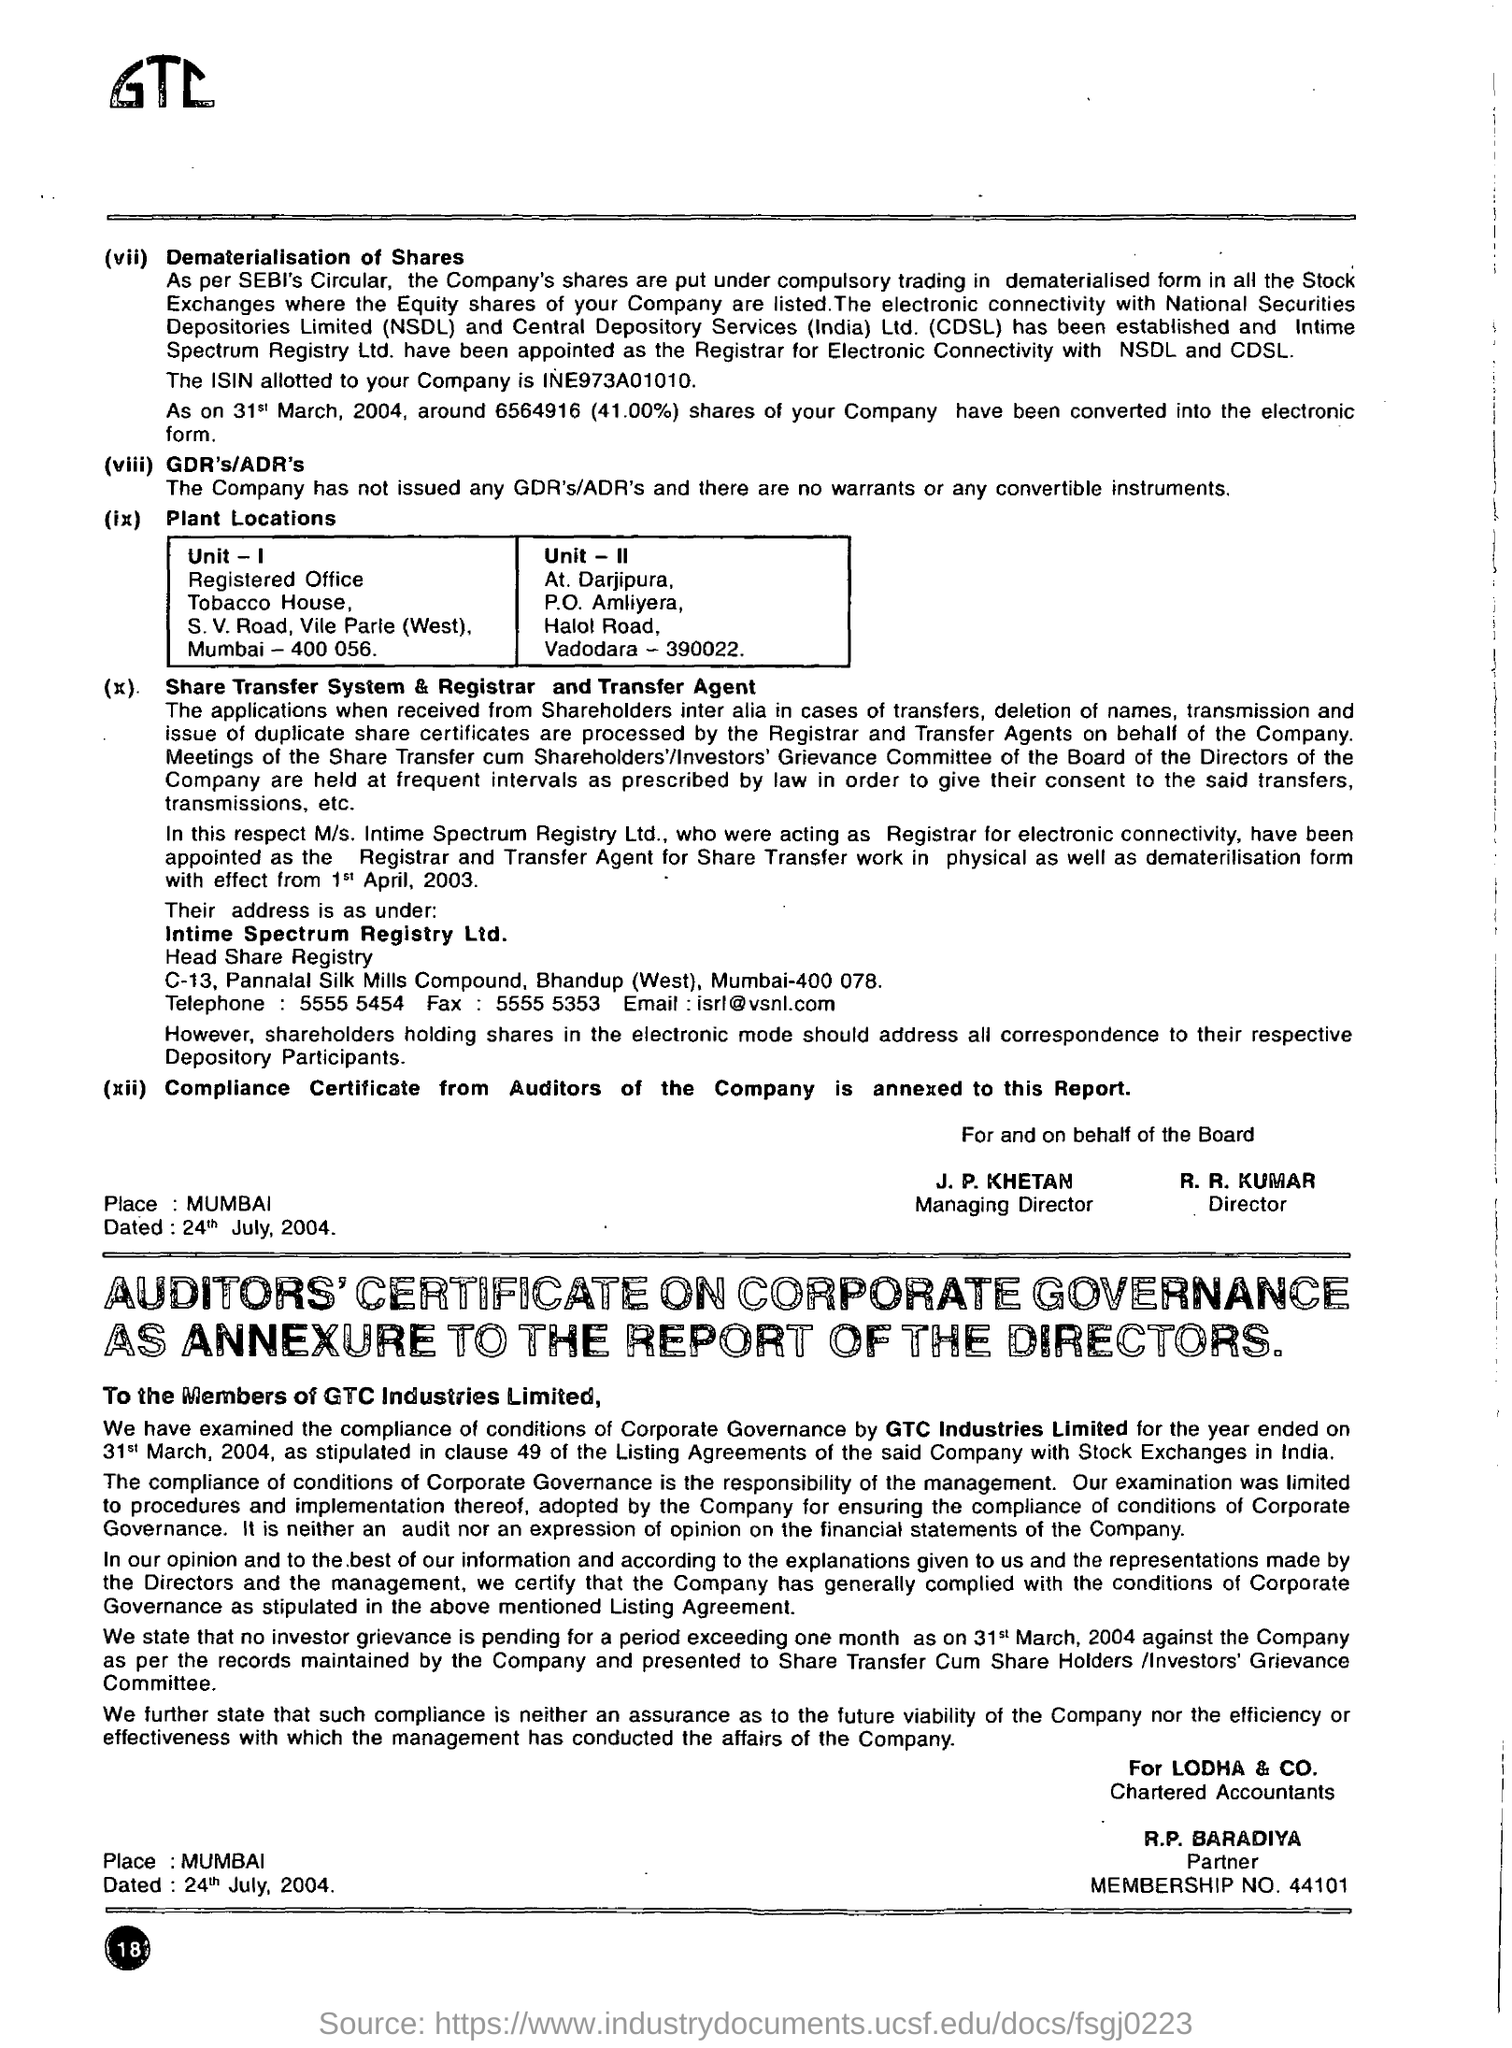What is the purpose of the dematerialisation of shares mentioned in the document? Dematerialisation of shares refers to the process of converting physical shares into electronic format. This process is aimed at enhancing the efficiency of share trading by making transactions quicker and less prone to errors, as well as improving overall security. 